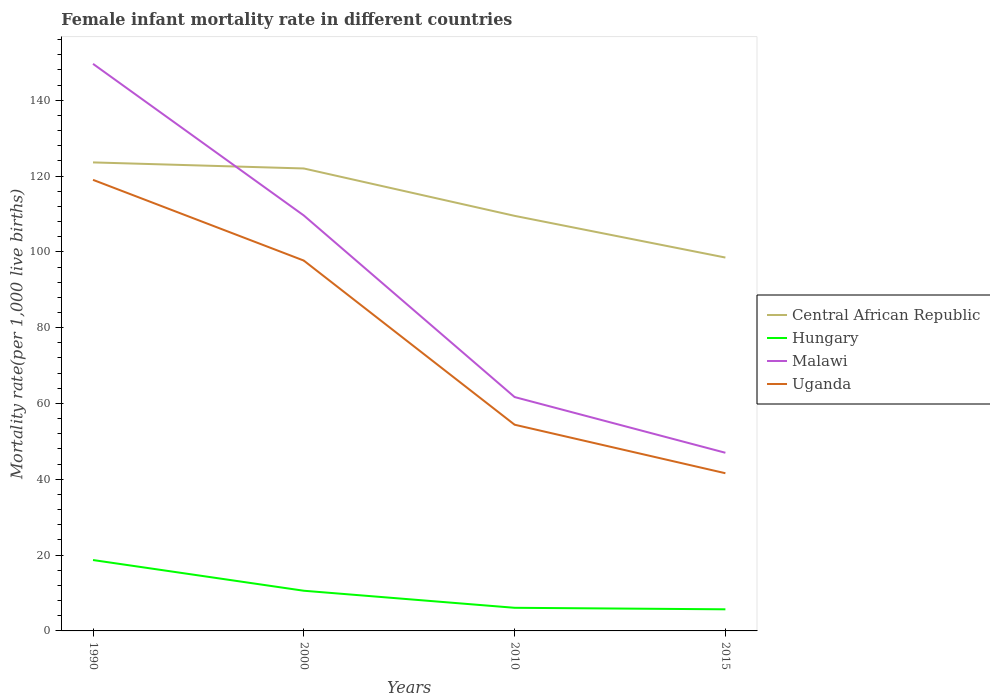Does the line corresponding to Malawi intersect with the line corresponding to Central African Republic?
Your response must be concise. Yes. Across all years, what is the maximum female infant mortality rate in Central African Republic?
Your answer should be very brief. 98.5. In which year was the female infant mortality rate in Uganda maximum?
Provide a short and direct response. 2015. What is the difference between the highest and the second highest female infant mortality rate in Central African Republic?
Your answer should be very brief. 25.1. What is the difference between the highest and the lowest female infant mortality rate in Malawi?
Make the answer very short. 2. Is the female infant mortality rate in Central African Republic strictly greater than the female infant mortality rate in Hungary over the years?
Your answer should be very brief. No. What is the difference between two consecutive major ticks on the Y-axis?
Your answer should be very brief. 20. Are the values on the major ticks of Y-axis written in scientific E-notation?
Ensure brevity in your answer.  No. Does the graph contain any zero values?
Make the answer very short. No. Does the graph contain grids?
Give a very brief answer. No. Where does the legend appear in the graph?
Give a very brief answer. Center right. How many legend labels are there?
Your answer should be very brief. 4. What is the title of the graph?
Your answer should be very brief. Female infant mortality rate in different countries. What is the label or title of the X-axis?
Your response must be concise. Years. What is the label or title of the Y-axis?
Offer a terse response. Mortality rate(per 1,0 live births). What is the Mortality rate(per 1,000 live births) of Central African Republic in 1990?
Your response must be concise. 123.6. What is the Mortality rate(per 1,000 live births) in Hungary in 1990?
Ensure brevity in your answer.  18.7. What is the Mortality rate(per 1,000 live births) of Malawi in 1990?
Your answer should be compact. 149.6. What is the Mortality rate(per 1,000 live births) of Uganda in 1990?
Keep it short and to the point. 119. What is the Mortality rate(per 1,000 live births) in Central African Republic in 2000?
Your answer should be compact. 122. What is the Mortality rate(per 1,000 live births) in Hungary in 2000?
Make the answer very short. 10.6. What is the Mortality rate(per 1,000 live births) of Malawi in 2000?
Provide a short and direct response. 109.6. What is the Mortality rate(per 1,000 live births) of Uganda in 2000?
Offer a very short reply. 97.7. What is the Mortality rate(per 1,000 live births) in Central African Republic in 2010?
Provide a short and direct response. 109.5. What is the Mortality rate(per 1,000 live births) in Malawi in 2010?
Your answer should be very brief. 61.7. What is the Mortality rate(per 1,000 live births) in Uganda in 2010?
Offer a very short reply. 54.4. What is the Mortality rate(per 1,000 live births) in Central African Republic in 2015?
Offer a terse response. 98.5. What is the Mortality rate(per 1,000 live births) in Uganda in 2015?
Your response must be concise. 41.6. Across all years, what is the maximum Mortality rate(per 1,000 live births) in Central African Republic?
Your answer should be very brief. 123.6. Across all years, what is the maximum Mortality rate(per 1,000 live births) of Malawi?
Give a very brief answer. 149.6. Across all years, what is the maximum Mortality rate(per 1,000 live births) of Uganda?
Give a very brief answer. 119. Across all years, what is the minimum Mortality rate(per 1,000 live births) of Central African Republic?
Your answer should be compact. 98.5. Across all years, what is the minimum Mortality rate(per 1,000 live births) of Hungary?
Ensure brevity in your answer.  5.7. Across all years, what is the minimum Mortality rate(per 1,000 live births) of Uganda?
Your response must be concise. 41.6. What is the total Mortality rate(per 1,000 live births) of Central African Republic in the graph?
Make the answer very short. 453.6. What is the total Mortality rate(per 1,000 live births) in Hungary in the graph?
Make the answer very short. 41.1. What is the total Mortality rate(per 1,000 live births) of Malawi in the graph?
Offer a terse response. 367.9. What is the total Mortality rate(per 1,000 live births) in Uganda in the graph?
Provide a short and direct response. 312.7. What is the difference between the Mortality rate(per 1,000 live births) of Hungary in 1990 and that in 2000?
Provide a succinct answer. 8.1. What is the difference between the Mortality rate(per 1,000 live births) in Uganda in 1990 and that in 2000?
Offer a very short reply. 21.3. What is the difference between the Mortality rate(per 1,000 live births) of Malawi in 1990 and that in 2010?
Give a very brief answer. 87.9. What is the difference between the Mortality rate(per 1,000 live births) of Uganda in 1990 and that in 2010?
Your answer should be very brief. 64.6. What is the difference between the Mortality rate(per 1,000 live births) of Central African Republic in 1990 and that in 2015?
Provide a succinct answer. 25.1. What is the difference between the Mortality rate(per 1,000 live births) in Malawi in 1990 and that in 2015?
Your response must be concise. 102.6. What is the difference between the Mortality rate(per 1,000 live births) of Uganda in 1990 and that in 2015?
Offer a terse response. 77.4. What is the difference between the Mortality rate(per 1,000 live births) of Central African Republic in 2000 and that in 2010?
Ensure brevity in your answer.  12.5. What is the difference between the Mortality rate(per 1,000 live births) in Hungary in 2000 and that in 2010?
Offer a very short reply. 4.5. What is the difference between the Mortality rate(per 1,000 live births) of Malawi in 2000 and that in 2010?
Your answer should be compact. 47.9. What is the difference between the Mortality rate(per 1,000 live births) in Uganda in 2000 and that in 2010?
Your answer should be very brief. 43.3. What is the difference between the Mortality rate(per 1,000 live births) of Malawi in 2000 and that in 2015?
Give a very brief answer. 62.6. What is the difference between the Mortality rate(per 1,000 live births) of Uganda in 2000 and that in 2015?
Your answer should be very brief. 56.1. What is the difference between the Mortality rate(per 1,000 live births) of Hungary in 2010 and that in 2015?
Keep it short and to the point. 0.4. What is the difference between the Mortality rate(per 1,000 live births) of Central African Republic in 1990 and the Mortality rate(per 1,000 live births) of Hungary in 2000?
Your response must be concise. 113. What is the difference between the Mortality rate(per 1,000 live births) in Central African Republic in 1990 and the Mortality rate(per 1,000 live births) in Malawi in 2000?
Offer a very short reply. 14. What is the difference between the Mortality rate(per 1,000 live births) of Central African Republic in 1990 and the Mortality rate(per 1,000 live births) of Uganda in 2000?
Your response must be concise. 25.9. What is the difference between the Mortality rate(per 1,000 live births) in Hungary in 1990 and the Mortality rate(per 1,000 live births) in Malawi in 2000?
Make the answer very short. -90.9. What is the difference between the Mortality rate(per 1,000 live births) in Hungary in 1990 and the Mortality rate(per 1,000 live births) in Uganda in 2000?
Ensure brevity in your answer.  -79. What is the difference between the Mortality rate(per 1,000 live births) of Malawi in 1990 and the Mortality rate(per 1,000 live births) of Uganda in 2000?
Offer a terse response. 51.9. What is the difference between the Mortality rate(per 1,000 live births) in Central African Republic in 1990 and the Mortality rate(per 1,000 live births) in Hungary in 2010?
Provide a succinct answer. 117.5. What is the difference between the Mortality rate(per 1,000 live births) in Central African Republic in 1990 and the Mortality rate(per 1,000 live births) in Malawi in 2010?
Keep it short and to the point. 61.9. What is the difference between the Mortality rate(per 1,000 live births) of Central African Republic in 1990 and the Mortality rate(per 1,000 live births) of Uganda in 2010?
Your answer should be compact. 69.2. What is the difference between the Mortality rate(per 1,000 live births) of Hungary in 1990 and the Mortality rate(per 1,000 live births) of Malawi in 2010?
Give a very brief answer. -43. What is the difference between the Mortality rate(per 1,000 live births) in Hungary in 1990 and the Mortality rate(per 1,000 live births) in Uganda in 2010?
Provide a short and direct response. -35.7. What is the difference between the Mortality rate(per 1,000 live births) of Malawi in 1990 and the Mortality rate(per 1,000 live births) of Uganda in 2010?
Provide a short and direct response. 95.2. What is the difference between the Mortality rate(per 1,000 live births) in Central African Republic in 1990 and the Mortality rate(per 1,000 live births) in Hungary in 2015?
Ensure brevity in your answer.  117.9. What is the difference between the Mortality rate(per 1,000 live births) of Central African Republic in 1990 and the Mortality rate(per 1,000 live births) of Malawi in 2015?
Your answer should be compact. 76.6. What is the difference between the Mortality rate(per 1,000 live births) in Central African Republic in 1990 and the Mortality rate(per 1,000 live births) in Uganda in 2015?
Ensure brevity in your answer.  82. What is the difference between the Mortality rate(per 1,000 live births) in Hungary in 1990 and the Mortality rate(per 1,000 live births) in Malawi in 2015?
Offer a terse response. -28.3. What is the difference between the Mortality rate(per 1,000 live births) of Hungary in 1990 and the Mortality rate(per 1,000 live births) of Uganda in 2015?
Offer a terse response. -22.9. What is the difference between the Mortality rate(per 1,000 live births) of Malawi in 1990 and the Mortality rate(per 1,000 live births) of Uganda in 2015?
Your response must be concise. 108. What is the difference between the Mortality rate(per 1,000 live births) of Central African Republic in 2000 and the Mortality rate(per 1,000 live births) of Hungary in 2010?
Keep it short and to the point. 115.9. What is the difference between the Mortality rate(per 1,000 live births) of Central African Republic in 2000 and the Mortality rate(per 1,000 live births) of Malawi in 2010?
Offer a very short reply. 60.3. What is the difference between the Mortality rate(per 1,000 live births) of Central African Republic in 2000 and the Mortality rate(per 1,000 live births) of Uganda in 2010?
Give a very brief answer. 67.6. What is the difference between the Mortality rate(per 1,000 live births) of Hungary in 2000 and the Mortality rate(per 1,000 live births) of Malawi in 2010?
Give a very brief answer. -51.1. What is the difference between the Mortality rate(per 1,000 live births) of Hungary in 2000 and the Mortality rate(per 1,000 live births) of Uganda in 2010?
Offer a terse response. -43.8. What is the difference between the Mortality rate(per 1,000 live births) of Malawi in 2000 and the Mortality rate(per 1,000 live births) of Uganda in 2010?
Provide a succinct answer. 55.2. What is the difference between the Mortality rate(per 1,000 live births) in Central African Republic in 2000 and the Mortality rate(per 1,000 live births) in Hungary in 2015?
Ensure brevity in your answer.  116.3. What is the difference between the Mortality rate(per 1,000 live births) of Central African Republic in 2000 and the Mortality rate(per 1,000 live births) of Uganda in 2015?
Your response must be concise. 80.4. What is the difference between the Mortality rate(per 1,000 live births) of Hungary in 2000 and the Mortality rate(per 1,000 live births) of Malawi in 2015?
Your response must be concise. -36.4. What is the difference between the Mortality rate(per 1,000 live births) of Hungary in 2000 and the Mortality rate(per 1,000 live births) of Uganda in 2015?
Your answer should be compact. -31. What is the difference between the Mortality rate(per 1,000 live births) of Malawi in 2000 and the Mortality rate(per 1,000 live births) of Uganda in 2015?
Ensure brevity in your answer.  68. What is the difference between the Mortality rate(per 1,000 live births) of Central African Republic in 2010 and the Mortality rate(per 1,000 live births) of Hungary in 2015?
Your answer should be compact. 103.8. What is the difference between the Mortality rate(per 1,000 live births) in Central African Republic in 2010 and the Mortality rate(per 1,000 live births) in Malawi in 2015?
Give a very brief answer. 62.5. What is the difference between the Mortality rate(per 1,000 live births) of Central African Republic in 2010 and the Mortality rate(per 1,000 live births) of Uganda in 2015?
Your answer should be very brief. 67.9. What is the difference between the Mortality rate(per 1,000 live births) in Hungary in 2010 and the Mortality rate(per 1,000 live births) in Malawi in 2015?
Provide a succinct answer. -40.9. What is the difference between the Mortality rate(per 1,000 live births) in Hungary in 2010 and the Mortality rate(per 1,000 live births) in Uganda in 2015?
Keep it short and to the point. -35.5. What is the difference between the Mortality rate(per 1,000 live births) of Malawi in 2010 and the Mortality rate(per 1,000 live births) of Uganda in 2015?
Your answer should be compact. 20.1. What is the average Mortality rate(per 1,000 live births) of Central African Republic per year?
Your answer should be very brief. 113.4. What is the average Mortality rate(per 1,000 live births) in Hungary per year?
Provide a succinct answer. 10.28. What is the average Mortality rate(per 1,000 live births) of Malawi per year?
Offer a very short reply. 91.97. What is the average Mortality rate(per 1,000 live births) in Uganda per year?
Your answer should be compact. 78.17. In the year 1990, what is the difference between the Mortality rate(per 1,000 live births) of Central African Republic and Mortality rate(per 1,000 live births) of Hungary?
Offer a very short reply. 104.9. In the year 1990, what is the difference between the Mortality rate(per 1,000 live births) in Central African Republic and Mortality rate(per 1,000 live births) in Malawi?
Make the answer very short. -26. In the year 1990, what is the difference between the Mortality rate(per 1,000 live births) of Central African Republic and Mortality rate(per 1,000 live births) of Uganda?
Offer a very short reply. 4.6. In the year 1990, what is the difference between the Mortality rate(per 1,000 live births) in Hungary and Mortality rate(per 1,000 live births) in Malawi?
Provide a short and direct response. -130.9. In the year 1990, what is the difference between the Mortality rate(per 1,000 live births) of Hungary and Mortality rate(per 1,000 live births) of Uganda?
Offer a terse response. -100.3. In the year 1990, what is the difference between the Mortality rate(per 1,000 live births) in Malawi and Mortality rate(per 1,000 live births) in Uganda?
Offer a very short reply. 30.6. In the year 2000, what is the difference between the Mortality rate(per 1,000 live births) of Central African Republic and Mortality rate(per 1,000 live births) of Hungary?
Provide a short and direct response. 111.4. In the year 2000, what is the difference between the Mortality rate(per 1,000 live births) of Central African Republic and Mortality rate(per 1,000 live births) of Malawi?
Make the answer very short. 12.4. In the year 2000, what is the difference between the Mortality rate(per 1,000 live births) of Central African Republic and Mortality rate(per 1,000 live births) of Uganda?
Give a very brief answer. 24.3. In the year 2000, what is the difference between the Mortality rate(per 1,000 live births) of Hungary and Mortality rate(per 1,000 live births) of Malawi?
Make the answer very short. -99. In the year 2000, what is the difference between the Mortality rate(per 1,000 live births) of Hungary and Mortality rate(per 1,000 live births) of Uganda?
Give a very brief answer. -87.1. In the year 2000, what is the difference between the Mortality rate(per 1,000 live births) in Malawi and Mortality rate(per 1,000 live births) in Uganda?
Provide a short and direct response. 11.9. In the year 2010, what is the difference between the Mortality rate(per 1,000 live births) of Central African Republic and Mortality rate(per 1,000 live births) of Hungary?
Give a very brief answer. 103.4. In the year 2010, what is the difference between the Mortality rate(per 1,000 live births) in Central African Republic and Mortality rate(per 1,000 live births) in Malawi?
Your answer should be compact. 47.8. In the year 2010, what is the difference between the Mortality rate(per 1,000 live births) of Central African Republic and Mortality rate(per 1,000 live births) of Uganda?
Provide a short and direct response. 55.1. In the year 2010, what is the difference between the Mortality rate(per 1,000 live births) in Hungary and Mortality rate(per 1,000 live births) in Malawi?
Give a very brief answer. -55.6. In the year 2010, what is the difference between the Mortality rate(per 1,000 live births) of Hungary and Mortality rate(per 1,000 live births) of Uganda?
Offer a very short reply. -48.3. In the year 2015, what is the difference between the Mortality rate(per 1,000 live births) in Central African Republic and Mortality rate(per 1,000 live births) in Hungary?
Keep it short and to the point. 92.8. In the year 2015, what is the difference between the Mortality rate(per 1,000 live births) of Central African Republic and Mortality rate(per 1,000 live births) of Malawi?
Make the answer very short. 51.5. In the year 2015, what is the difference between the Mortality rate(per 1,000 live births) of Central African Republic and Mortality rate(per 1,000 live births) of Uganda?
Your answer should be very brief. 56.9. In the year 2015, what is the difference between the Mortality rate(per 1,000 live births) in Hungary and Mortality rate(per 1,000 live births) in Malawi?
Offer a very short reply. -41.3. In the year 2015, what is the difference between the Mortality rate(per 1,000 live births) in Hungary and Mortality rate(per 1,000 live births) in Uganda?
Provide a succinct answer. -35.9. What is the ratio of the Mortality rate(per 1,000 live births) of Central African Republic in 1990 to that in 2000?
Your response must be concise. 1.01. What is the ratio of the Mortality rate(per 1,000 live births) of Hungary in 1990 to that in 2000?
Give a very brief answer. 1.76. What is the ratio of the Mortality rate(per 1,000 live births) of Malawi in 1990 to that in 2000?
Provide a short and direct response. 1.36. What is the ratio of the Mortality rate(per 1,000 live births) of Uganda in 1990 to that in 2000?
Ensure brevity in your answer.  1.22. What is the ratio of the Mortality rate(per 1,000 live births) in Central African Republic in 1990 to that in 2010?
Offer a very short reply. 1.13. What is the ratio of the Mortality rate(per 1,000 live births) in Hungary in 1990 to that in 2010?
Provide a succinct answer. 3.07. What is the ratio of the Mortality rate(per 1,000 live births) of Malawi in 1990 to that in 2010?
Offer a terse response. 2.42. What is the ratio of the Mortality rate(per 1,000 live births) of Uganda in 1990 to that in 2010?
Provide a succinct answer. 2.19. What is the ratio of the Mortality rate(per 1,000 live births) in Central African Republic in 1990 to that in 2015?
Offer a terse response. 1.25. What is the ratio of the Mortality rate(per 1,000 live births) in Hungary in 1990 to that in 2015?
Your answer should be compact. 3.28. What is the ratio of the Mortality rate(per 1,000 live births) in Malawi in 1990 to that in 2015?
Keep it short and to the point. 3.18. What is the ratio of the Mortality rate(per 1,000 live births) of Uganda in 1990 to that in 2015?
Your response must be concise. 2.86. What is the ratio of the Mortality rate(per 1,000 live births) in Central African Republic in 2000 to that in 2010?
Offer a very short reply. 1.11. What is the ratio of the Mortality rate(per 1,000 live births) in Hungary in 2000 to that in 2010?
Your answer should be compact. 1.74. What is the ratio of the Mortality rate(per 1,000 live births) in Malawi in 2000 to that in 2010?
Your answer should be very brief. 1.78. What is the ratio of the Mortality rate(per 1,000 live births) of Uganda in 2000 to that in 2010?
Your answer should be very brief. 1.8. What is the ratio of the Mortality rate(per 1,000 live births) of Central African Republic in 2000 to that in 2015?
Provide a succinct answer. 1.24. What is the ratio of the Mortality rate(per 1,000 live births) in Hungary in 2000 to that in 2015?
Provide a short and direct response. 1.86. What is the ratio of the Mortality rate(per 1,000 live births) in Malawi in 2000 to that in 2015?
Ensure brevity in your answer.  2.33. What is the ratio of the Mortality rate(per 1,000 live births) in Uganda in 2000 to that in 2015?
Offer a terse response. 2.35. What is the ratio of the Mortality rate(per 1,000 live births) in Central African Republic in 2010 to that in 2015?
Give a very brief answer. 1.11. What is the ratio of the Mortality rate(per 1,000 live births) of Hungary in 2010 to that in 2015?
Your answer should be compact. 1.07. What is the ratio of the Mortality rate(per 1,000 live births) of Malawi in 2010 to that in 2015?
Make the answer very short. 1.31. What is the ratio of the Mortality rate(per 1,000 live births) of Uganda in 2010 to that in 2015?
Make the answer very short. 1.31. What is the difference between the highest and the second highest Mortality rate(per 1,000 live births) of Central African Republic?
Provide a short and direct response. 1.6. What is the difference between the highest and the second highest Mortality rate(per 1,000 live births) of Malawi?
Your response must be concise. 40. What is the difference between the highest and the second highest Mortality rate(per 1,000 live births) of Uganda?
Your answer should be compact. 21.3. What is the difference between the highest and the lowest Mortality rate(per 1,000 live births) in Central African Republic?
Make the answer very short. 25.1. What is the difference between the highest and the lowest Mortality rate(per 1,000 live births) of Malawi?
Ensure brevity in your answer.  102.6. What is the difference between the highest and the lowest Mortality rate(per 1,000 live births) of Uganda?
Make the answer very short. 77.4. 